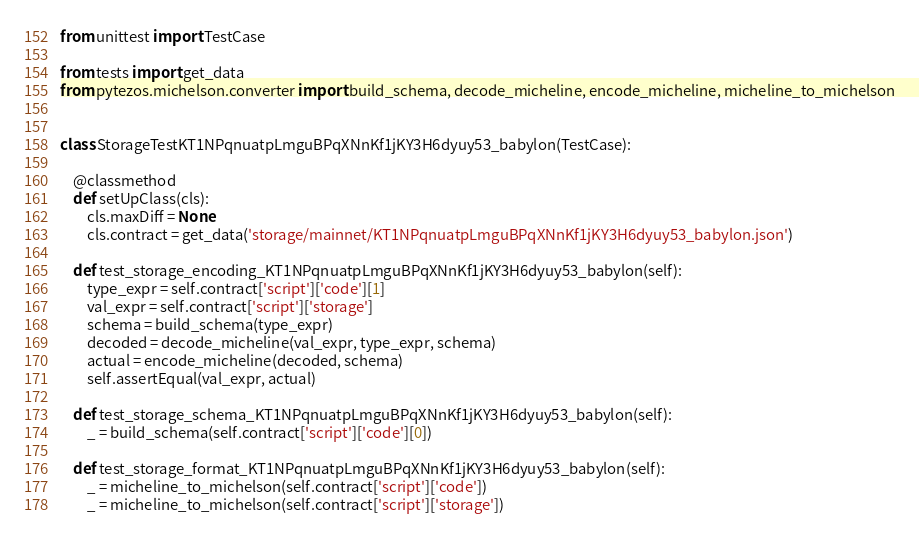<code> <loc_0><loc_0><loc_500><loc_500><_Python_>from unittest import TestCase

from tests import get_data
from pytezos.michelson.converter import build_schema, decode_micheline, encode_micheline, micheline_to_michelson


class StorageTestKT1NPqnuatpLmguBPqXNnKf1jKY3H6dyuy53_babylon(TestCase):

    @classmethod
    def setUpClass(cls):
        cls.maxDiff = None
        cls.contract = get_data('storage/mainnet/KT1NPqnuatpLmguBPqXNnKf1jKY3H6dyuy53_babylon.json')

    def test_storage_encoding_KT1NPqnuatpLmguBPqXNnKf1jKY3H6dyuy53_babylon(self):
        type_expr = self.contract['script']['code'][1]
        val_expr = self.contract['script']['storage']
        schema = build_schema(type_expr)
        decoded = decode_micheline(val_expr, type_expr, schema)
        actual = encode_micheline(decoded, schema)
        self.assertEqual(val_expr, actual)

    def test_storage_schema_KT1NPqnuatpLmguBPqXNnKf1jKY3H6dyuy53_babylon(self):
        _ = build_schema(self.contract['script']['code'][0])

    def test_storage_format_KT1NPqnuatpLmguBPqXNnKf1jKY3H6dyuy53_babylon(self):
        _ = micheline_to_michelson(self.contract['script']['code'])
        _ = micheline_to_michelson(self.contract['script']['storage'])
</code> 